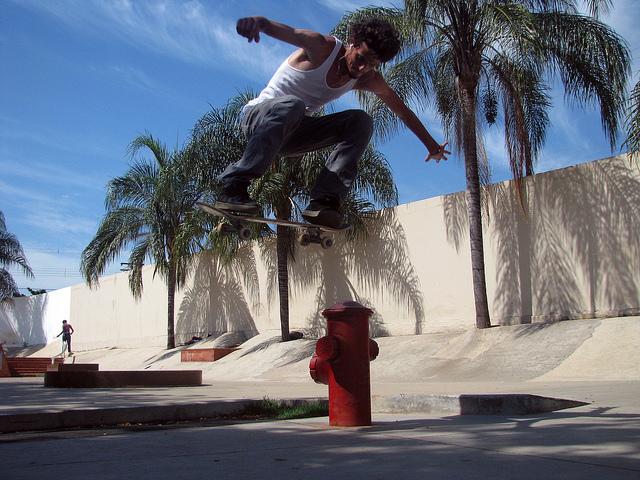What firefighting device is right below the moving skateboarder?
Answer briefly. Hydrant. What has cast shadows?
Write a very short answer. Trees. What are the trees in the background?
Quick response, please. Palm. 